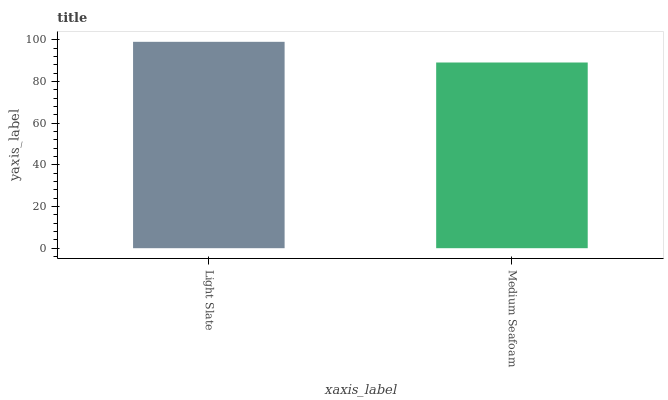Is Medium Seafoam the maximum?
Answer yes or no. No. Is Light Slate greater than Medium Seafoam?
Answer yes or no. Yes. Is Medium Seafoam less than Light Slate?
Answer yes or no. Yes. Is Medium Seafoam greater than Light Slate?
Answer yes or no. No. Is Light Slate less than Medium Seafoam?
Answer yes or no. No. Is Light Slate the high median?
Answer yes or no. Yes. Is Medium Seafoam the low median?
Answer yes or no. Yes. Is Medium Seafoam the high median?
Answer yes or no. No. Is Light Slate the low median?
Answer yes or no. No. 